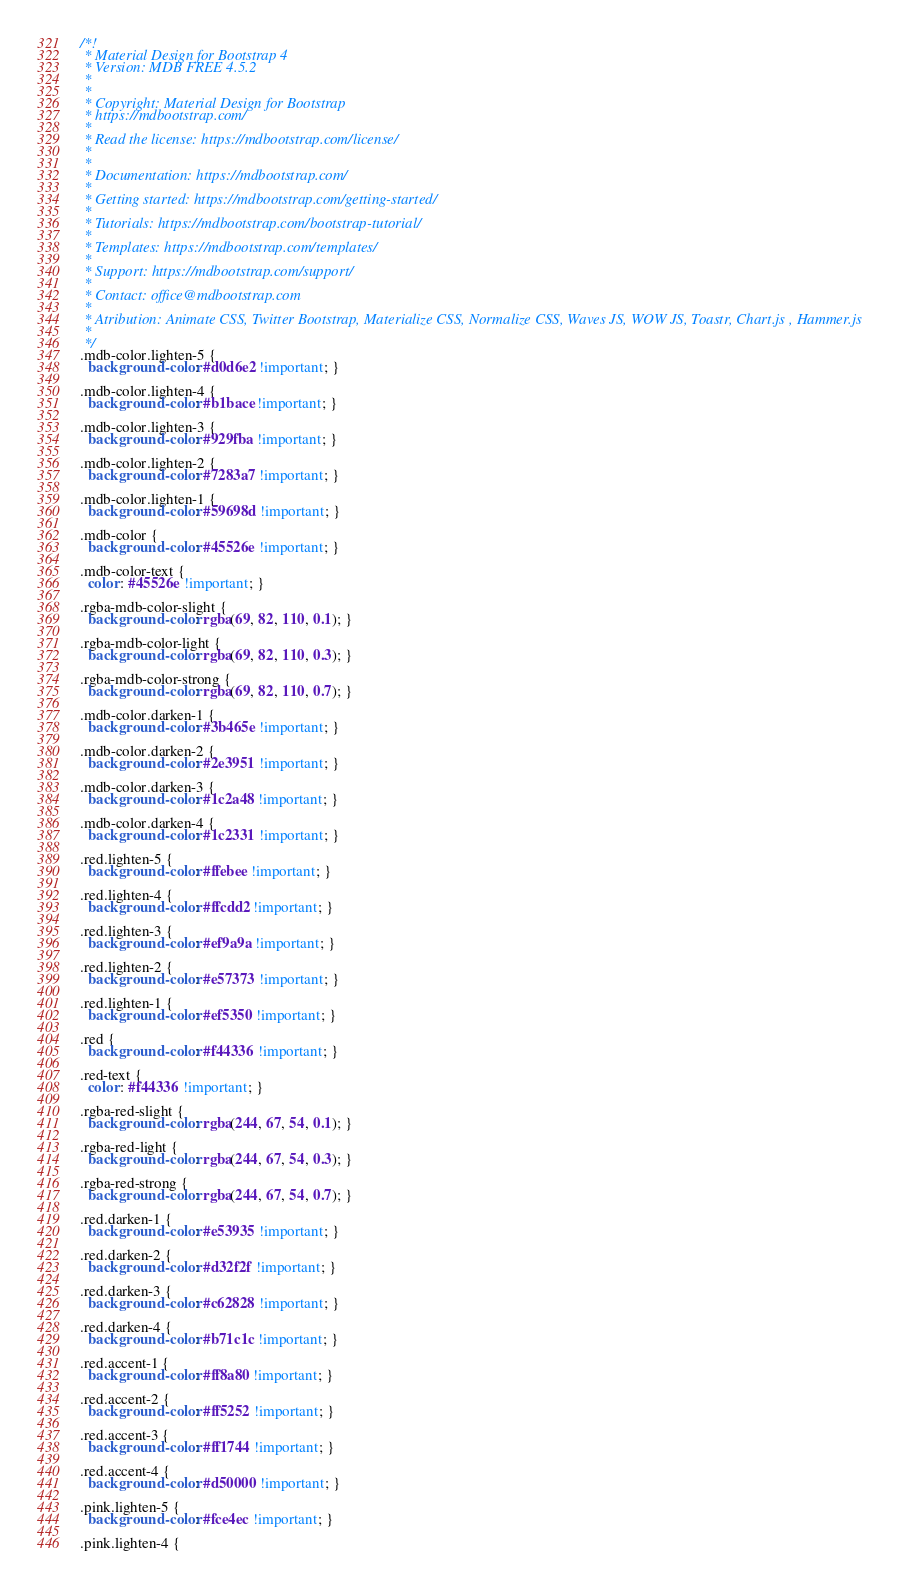<code> <loc_0><loc_0><loc_500><loc_500><_CSS_>/*!
 * Material Design for Bootstrap 4
 * Version: MDB FREE 4.5.2
 *
 *
 * Copyright: Material Design for Bootstrap
 * https://mdbootstrap.com/
 *
 * Read the license: https://mdbootstrap.com/license/
 *
 *
 * Documentation: https://mdbootstrap.com/
 *
 * Getting started: https://mdbootstrap.com/getting-started/
 *
 * Tutorials: https://mdbootstrap.com/bootstrap-tutorial/
 *
 * Templates: https://mdbootstrap.com/templates/
 *
 * Support: https://mdbootstrap.com/support/
 *
 * Contact: office@mdbootstrap.com
 *
 * Atribution: Animate CSS, Twitter Bootstrap, Materialize CSS, Normalize CSS, Waves JS, WOW JS, Toastr, Chart.js , Hammer.js
 *
 */
.mdb-color.lighten-5 {
  background-color: #d0d6e2 !important; }

.mdb-color.lighten-4 {
  background-color: #b1bace !important; }

.mdb-color.lighten-3 {
  background-color: #929fba !important; }

.mdb-color.lighten-2 {
  background-color: #7283a7 !important; }

.mdb-color.lighten-1 {
  background-color: #59698d !important; }

.mdb-color {
  background-color: #45526e !important; }

.mdb-color-text {
  color: #45526e !important; }

.rgba-mdb-color-slight {
  background-color: rgba(69, 82, 110, 0.1); }

.rgba-mdb-color-light {
  background-color: rgba(69, 82, 110, 0.3); }

.rgba-mdb-color-strong {
  background-color: rgba(69, 82, 110, 0.7); }

.mdb-color.darken-1 {
  background-color: #3b465e !important; }

.mdb-color.darken-2 {
  background-color: #2e3951 !important; }

.mdb-color.darken-3 {
  background-color: #1c2a48 !important; }

.mdb-color.darken-4 {
  background-color: #1c2331 !important; }

.red.lighten-5 {
  background-color: #ffebee !important; }

.red.lighten-4 {
  background-color: #ffcdd2 !important; }

.red.lighten-3 {
  background-color: #ef9a9a !important; }

.red.lighten-2 {
  background-color: #e57373 !important; }

.red.lighten-1 {
  background-color: #ef5350 !important; }

.red {
  background-color: #f44336 !important; }

.red-text {
  color: #f44336 !important; }

.rgba-red-slight {
  background-color: rgba(244, 67, 54, 0.1); }

.rgba-red-light {
  background-color: rgba(244, 67, 54, 0.3); }

.rgba-red-strong {
  background-color: rgba(244, 67, 54, 0.7); }

.red.darken-1 {
  background-color: #e53935 !important; }

.red.darken-2 {
  background-color: #d32f2f !important; }

.red.darken-3 {
  background-color: #c62828 !important; }

.red.darken-4 {
  background-color: #b71c1c !important; }

.red.accent-1 {
  background-color: #ff8a80 !important; }

.red.accent-2 {
  background-color: #ff5252 !important; }

.red.accent-3 {
  background-color: #ff1744 !important; }

.red.accent-4 {
  background-color: #d50000 !important; }

.pink.lighten-5 {
  background-color: #fce4ec !important; }

.pink.lighten-4 {</code> 